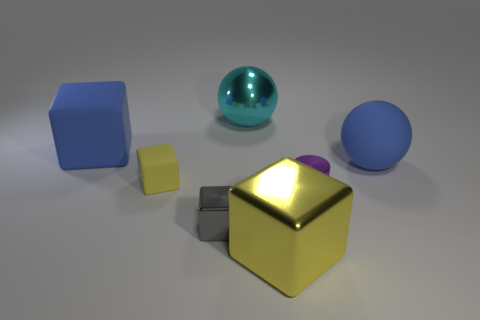How would you describe the different textures visible in this image? The image showcases a variety of textures. The metallic cube in the foreground reflects light smoothly, indicating a polished surface. The matte yellow cube looks soft and slightly textured, possibly resembling a painted or plastic finish. The blue sphere has a glossy texture, like glass or polished stone, while the background surface is diffuse, neither fully matte nor reflective, hinting at a possibly synthetic or rubberized material. 